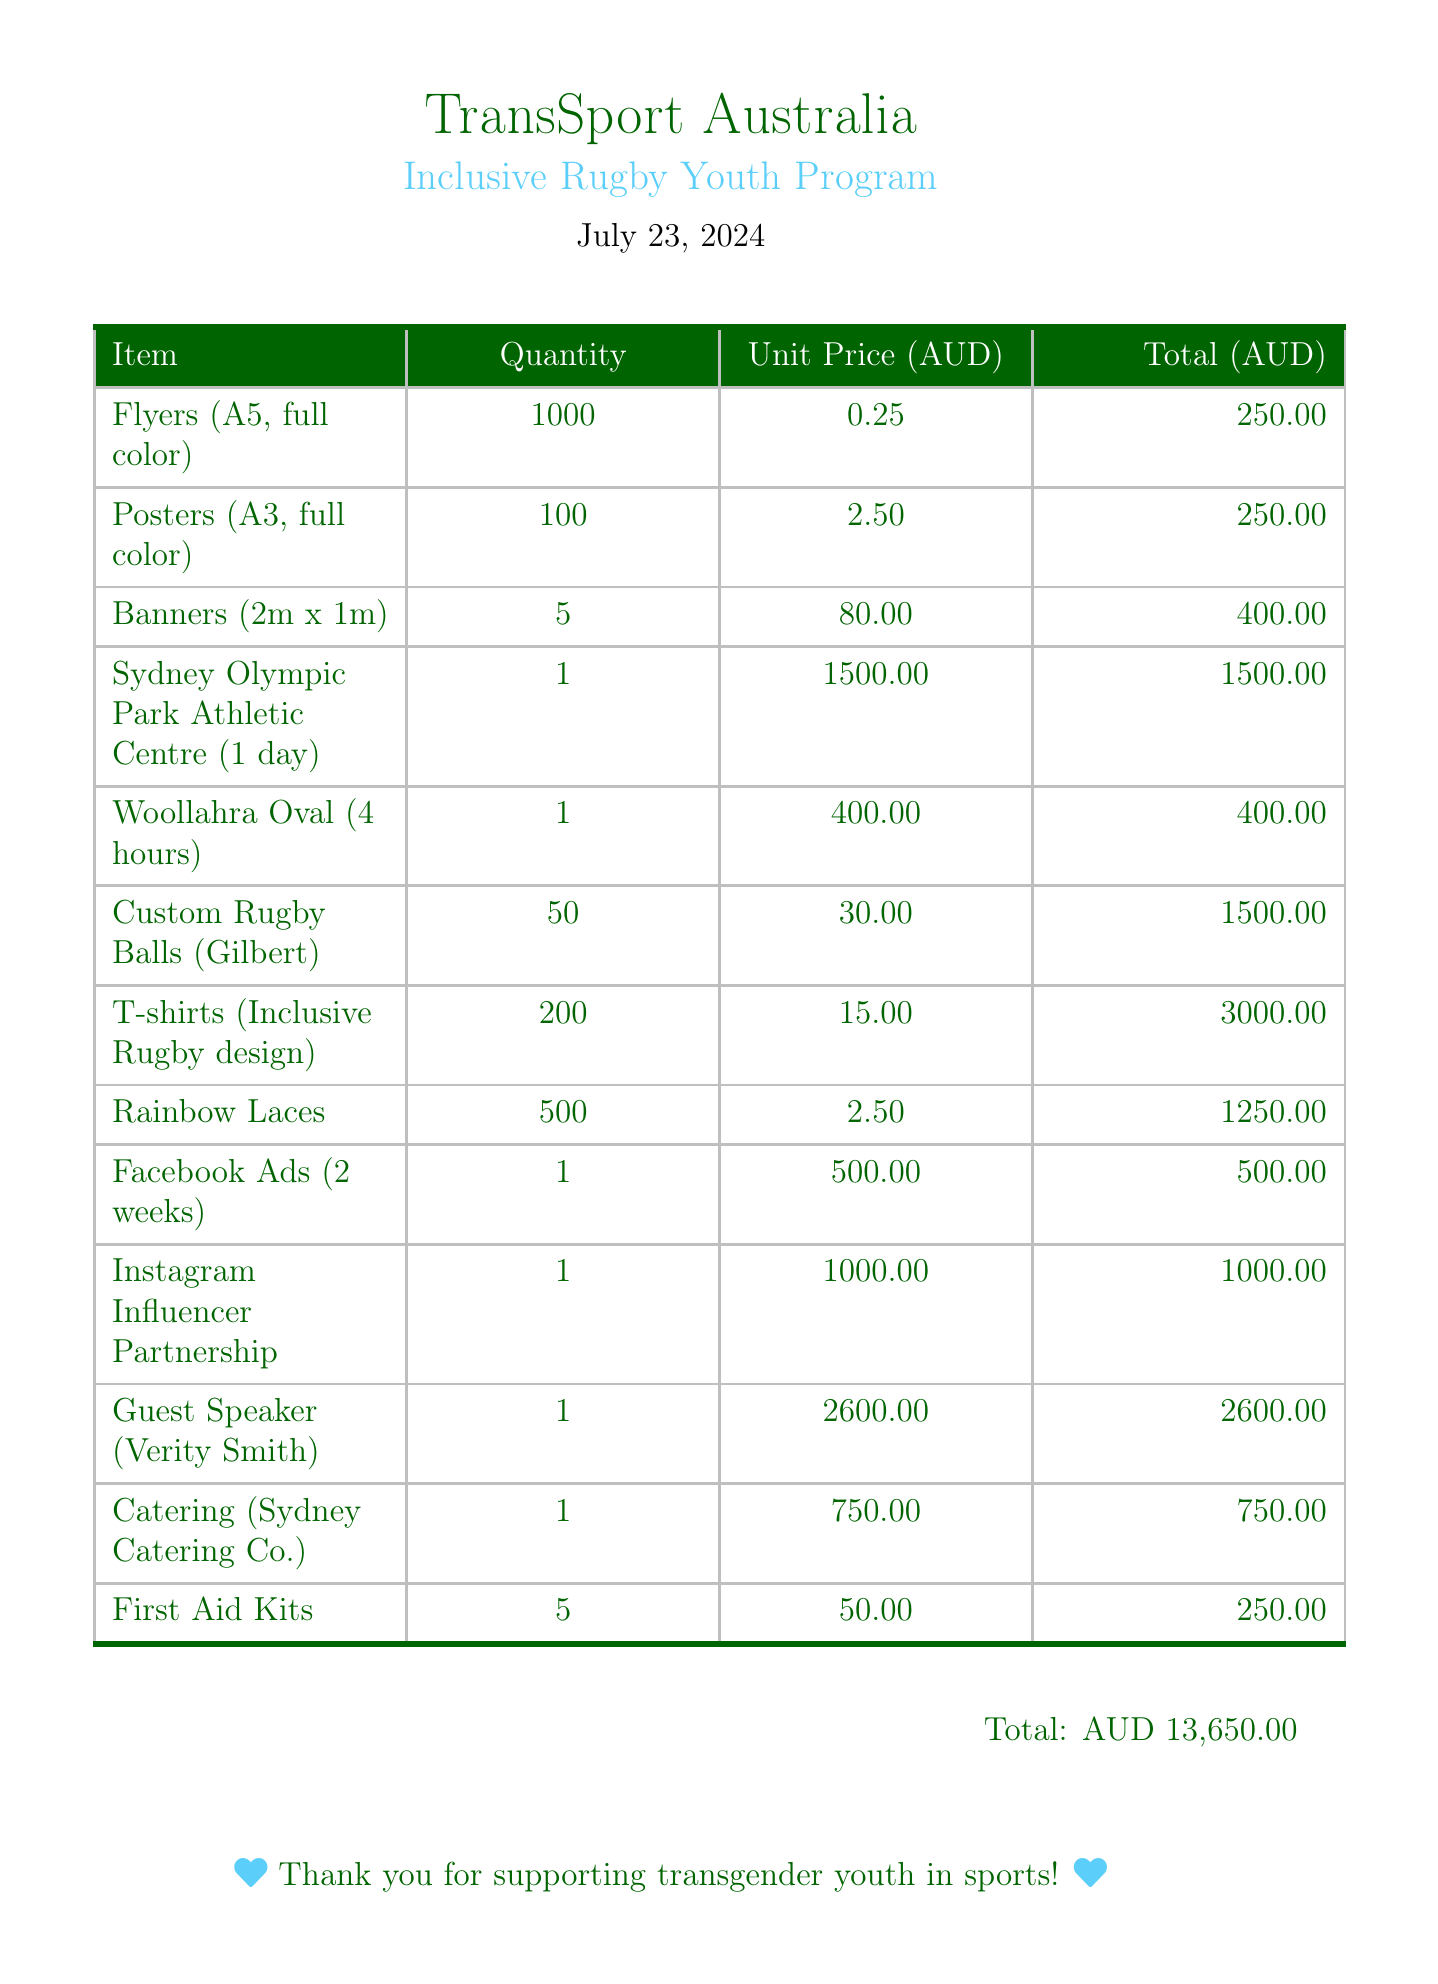what is the organization name? The organization name is found at the top of the document.
Answer: TransSport Australia what is the campaign name? The campaign name is displayed prominently beneath the organization name.
Answer: Inclusive Rugby Youth Program what is the date of the invoice? The date is mentioned near the campaign name in the document.
Answer: 2023-05-15 how much was spent on printing costs? The total for printing costs is calculated from the individual items listed in the document.
Answer: 900.00 what is the total cost of venue rentals? Venue rentals costs are summed from the specified venues in the document.
Answer: 1900.00 how many custom rugby balls were ordered? The quantity of custom rugby balls is stated in the promotional materials section.
Answer: 50 what is the fee for the guest speaker? The fee for the guest speaker is listed as a specific cost in the document.
Answer: 1500.00 how much was allocated for digital marketing? The costs of digital marketing are combined from the individual entries in that section.
Answer: 1500.00 what is the total amount of the invoice? The total amount appears at the end of the document.
Answer: 13650.00 